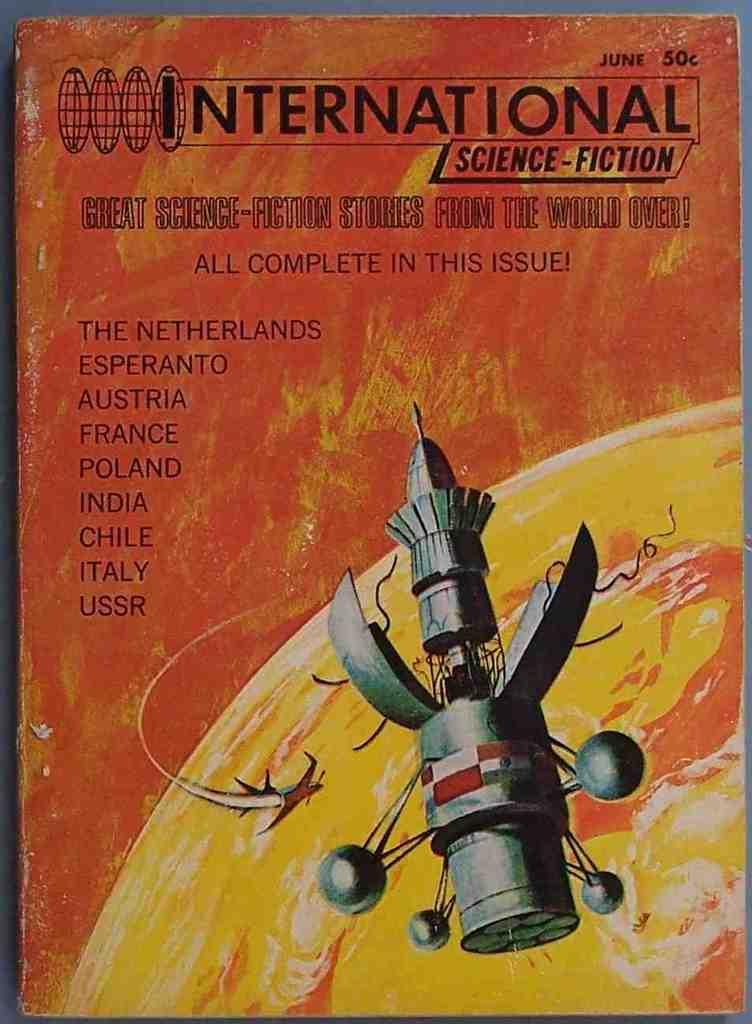<image>
Share a concise interpretation of the image provided. the cover of the book intrnational space station with an illustration of it. 